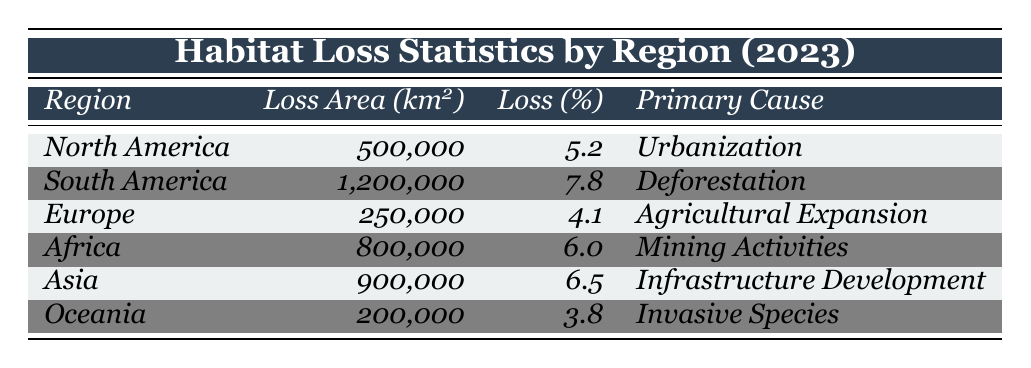What is the total habitat loss area in South America? According to the table, the habitat loss area for South America is listed as 1,200,000 km².
Answer: 1,200,000 km² Which region experienced the highest percentage of habitat loss? The table shows that South America has the highest percentage loss at 7.8%.
Answer: South America What is the total habitat loss area for both North America and Europe combined? To find the combined area, add North America's loss (500,000 km²) and Europe's loss (250,000 km²): 500,000 + 250,000 = 750,000 km².
Answer: 750,000 km² Is the primary cause of habitat loss in Africa mining activities? The table states that Africa's primary cause of habitat loss is indeed mining activities, so the statement is true.
Answer: Yes What is the average percentage loss of habitat across all regions? Calculate the average by summing the percentages: (5.2 + 7.8 + 4.1 + 6.0 + 6.5 + 3.8) / 6 = 5.22%.
Answer: 5.22% Which region has the least amount of habitat loss, and what is its primary cause? The table shows Oceania with the least loss (200,000 km²), and its primary cause is invasive species.
Answer: Oceania; Invasive Species What is the difference in habitat loss area between Asia and North America? The area for Asia is 900,000 km² and for North America it is 500,000 km². The difference is: 900,000 - 500,000 = 400,000 km².
Answer: 400,000 km² If we consider only the percentage losses, which two regions have losses that are closest in value? The closest percentages are Africa (6.0%) and Asia (6.5%). The difference between them is 0.5%.
Answer: Africa and Asia How many regions reported a percentage loss of habitat greater than 5%? Looking at the table: South America (7.8%), Africa (6.0%), and Asia (6.5%) indicate the regions above 5%. That makes 3 regions.
Answer: 3 regions Is urbanization a primary cause of habitat loss in Europe? The table indicates that the primary cause of habitat loss in Europe is agricultural expansion, making this statement false.
Answer: No 